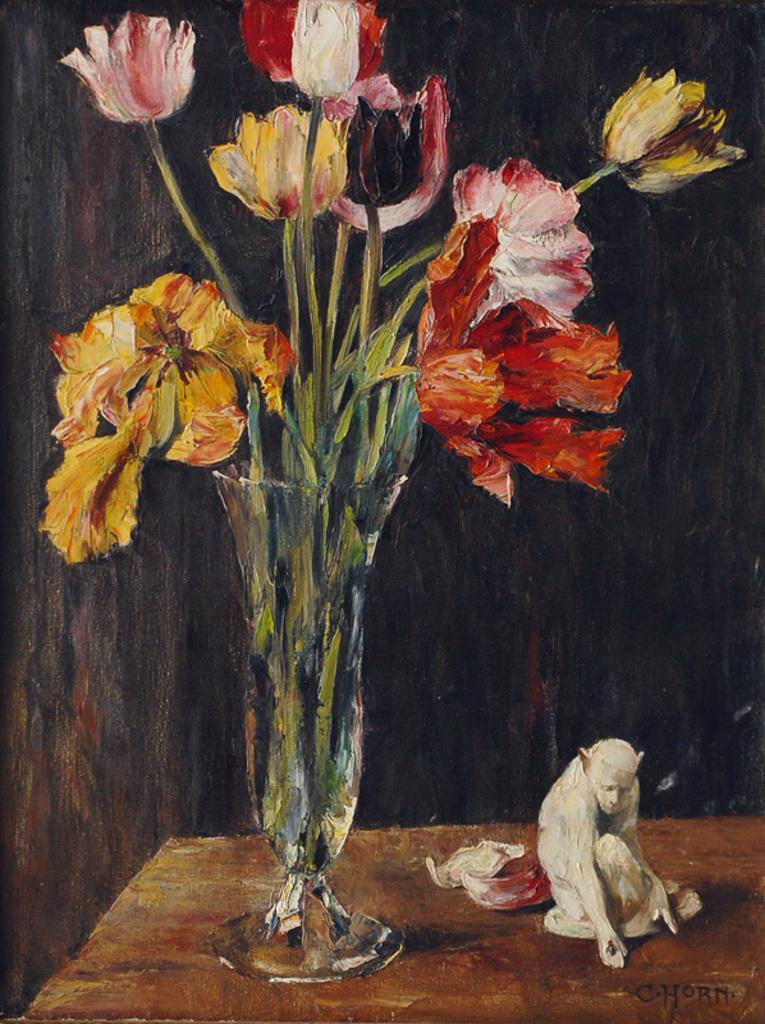What is the main object in the image? There is a flower vase in the image. What can be seen inside the vase? There are different color flowers in the vase. What other object is present in the image? There is a white color statue in the image. What is the color of the table in the image? The table is brown in color. What color is the background of the image? The background of the image is black. How does the statue use a comb in the image? There is no comb present in the image, and the statue is not shown performing any actions. 